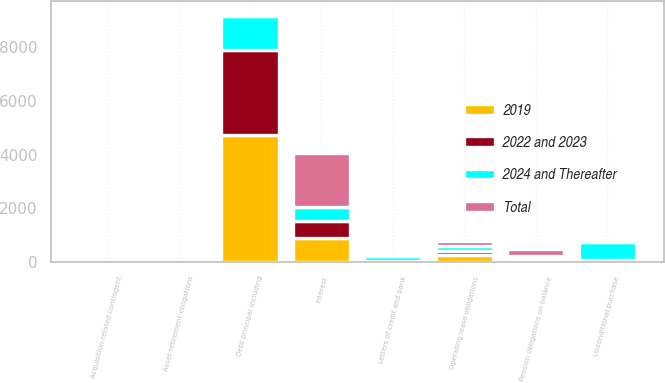Convert chart. <chart><loc_0><loc_0><loc_500><loc_500><stacked_bar_chart><ecel><fcel>Debt principal including<fcel>Interest<fcel>Operating lease obligations<fcel>Unconditional purchase<fcel>Letters of credit and bank<fcel>Pension obligations on balance<fcel>Asset retirement obligations<fcel>Acquisition-related contingent<nl><fcel>2024 and Thereafter<fcel>1268<fcel>522<fcel>192<fcel>673<fcel>183<fcel>43<fcel>6<fcel>3<nl><fcel>2019<fcel>4727<fcel>915<fcel>276<fcel>46<fcel>19<fcel>91<fcel>15<fcel>13<nl><fcel>2022 and 2023<fcel>3175<fcel>621<fcel>144<fcel>21<fcel>13<fcel>97<fcel>11<fcel>5<nl><fcel>Total<fcel>91<fcel>1990<fcel>177<fcel>5<fcel>3<fcel>274<fcel>13<fcel>16<nl></chart> 